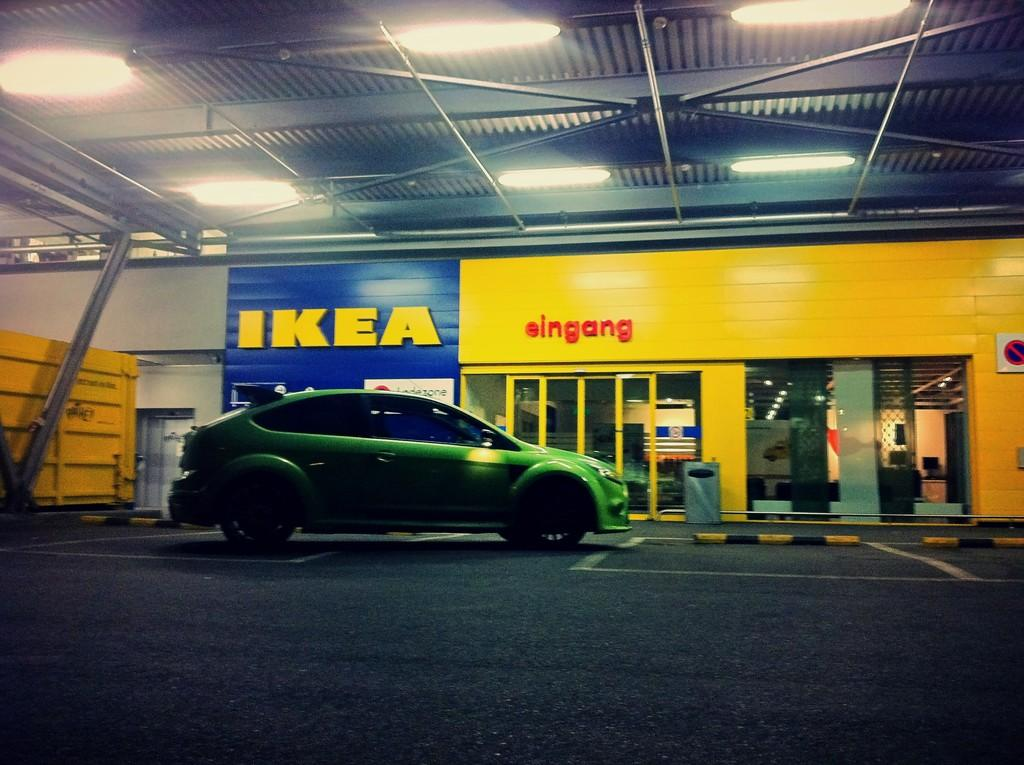What type of vehicle is in the image? There is a green car in the image. What can be seen in the background of the image? There is an IKEA store and glass doors in the background of the image. What architectural feature is visible in the background? There are glass doors in the background of the image. What is visible at the top of the image? The roof and lights are present at the top of the image. Can you tell me how many zebras are flying a kite in the image? There are no zebras or kites present in the image. Who is the representative of the car in the image? The image does not depict a car representative; it simply shows a green car. 